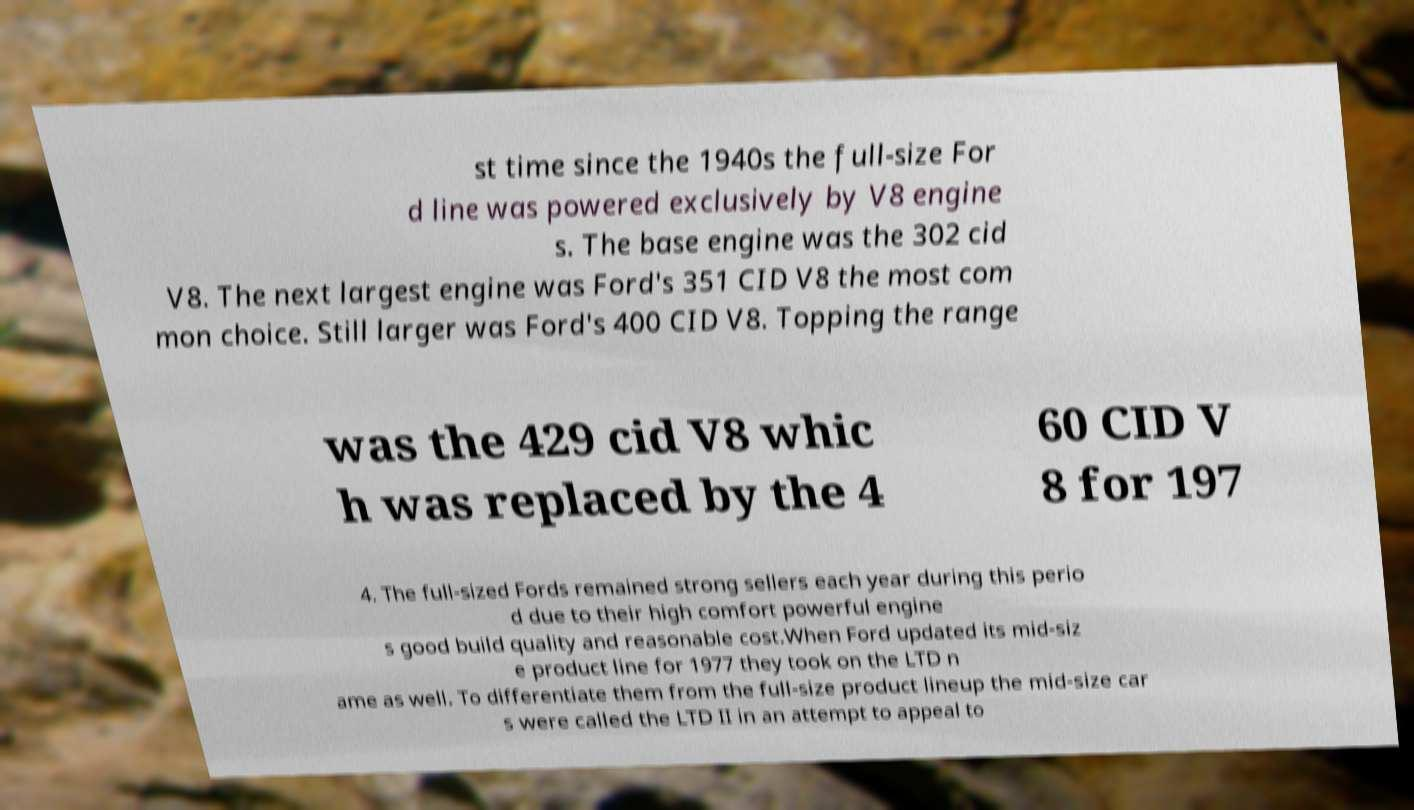Can you accurately transcribe the text from the provided image for me? st time since the 1940s the full-size For d line was powered exclusively by V8 engine s. The base engine was the 302 cid V8. The next largest engine was Ford's 351 CID V8 the most com mon choice. Still larger was Ford's 400 CID V8. Topping the range was the 429 cid V8 whic h was replaced by the 4 60 CID V 8 for 197 4. The full-sized Fords remained strong sellers each year during this perio d due to their high comfort powerful engine s good build quality and reasonable cost.When Ford updated its mid-siz e product line for 1977 they took on the LTD n ame as well. To differentiate them from the full-size product lineup the mid-size car s were called the LTD II in an attempt to appeal to 